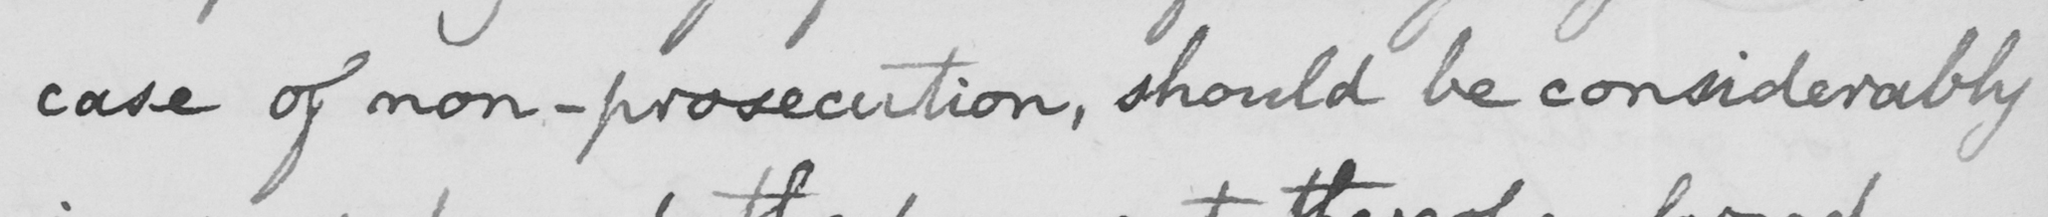Please provide the text content of this handwritten line. case of non-prosecution, should be considerably 